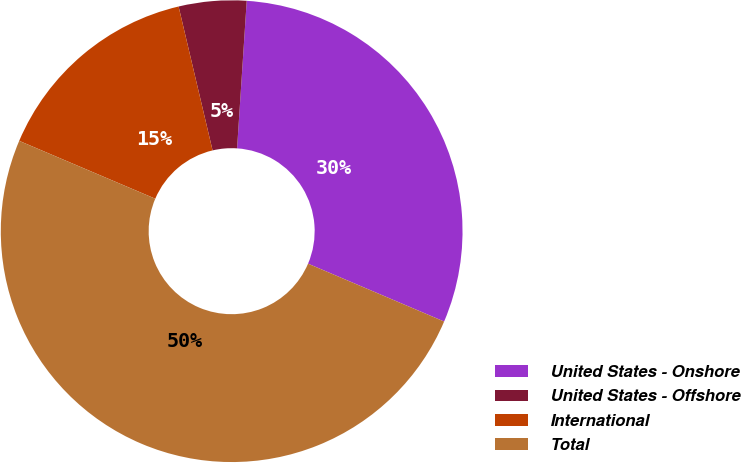Convert chart to OTSL. <chart><loc_0><loc_0><loc_500><loc_500><pie_chart><fcel>United States - Onshore<fcel>United States - Offshore<fcel>International<fcel>Total<nl><fcel>30.36%<fcel>4.73%<fcel>14.91%<fcel>50.0%<nl></chart> 